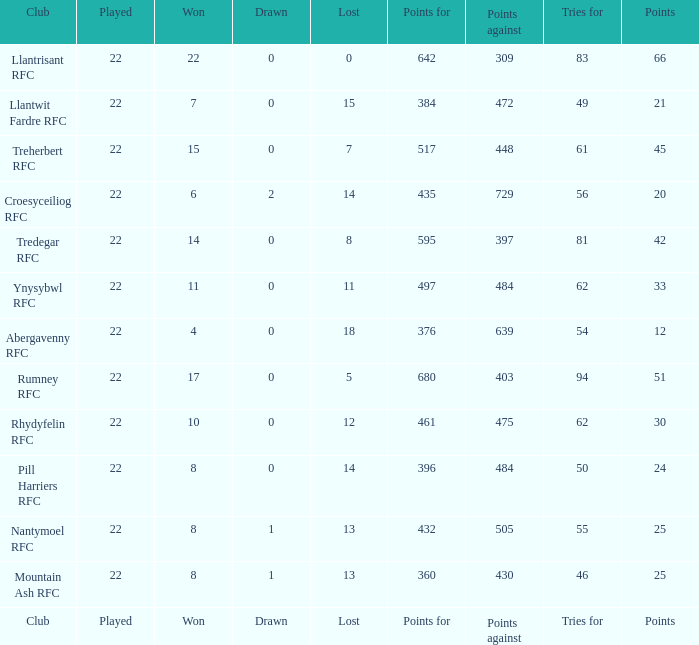How many matches were drawn by the teams that won exactly 10? 1.0. 